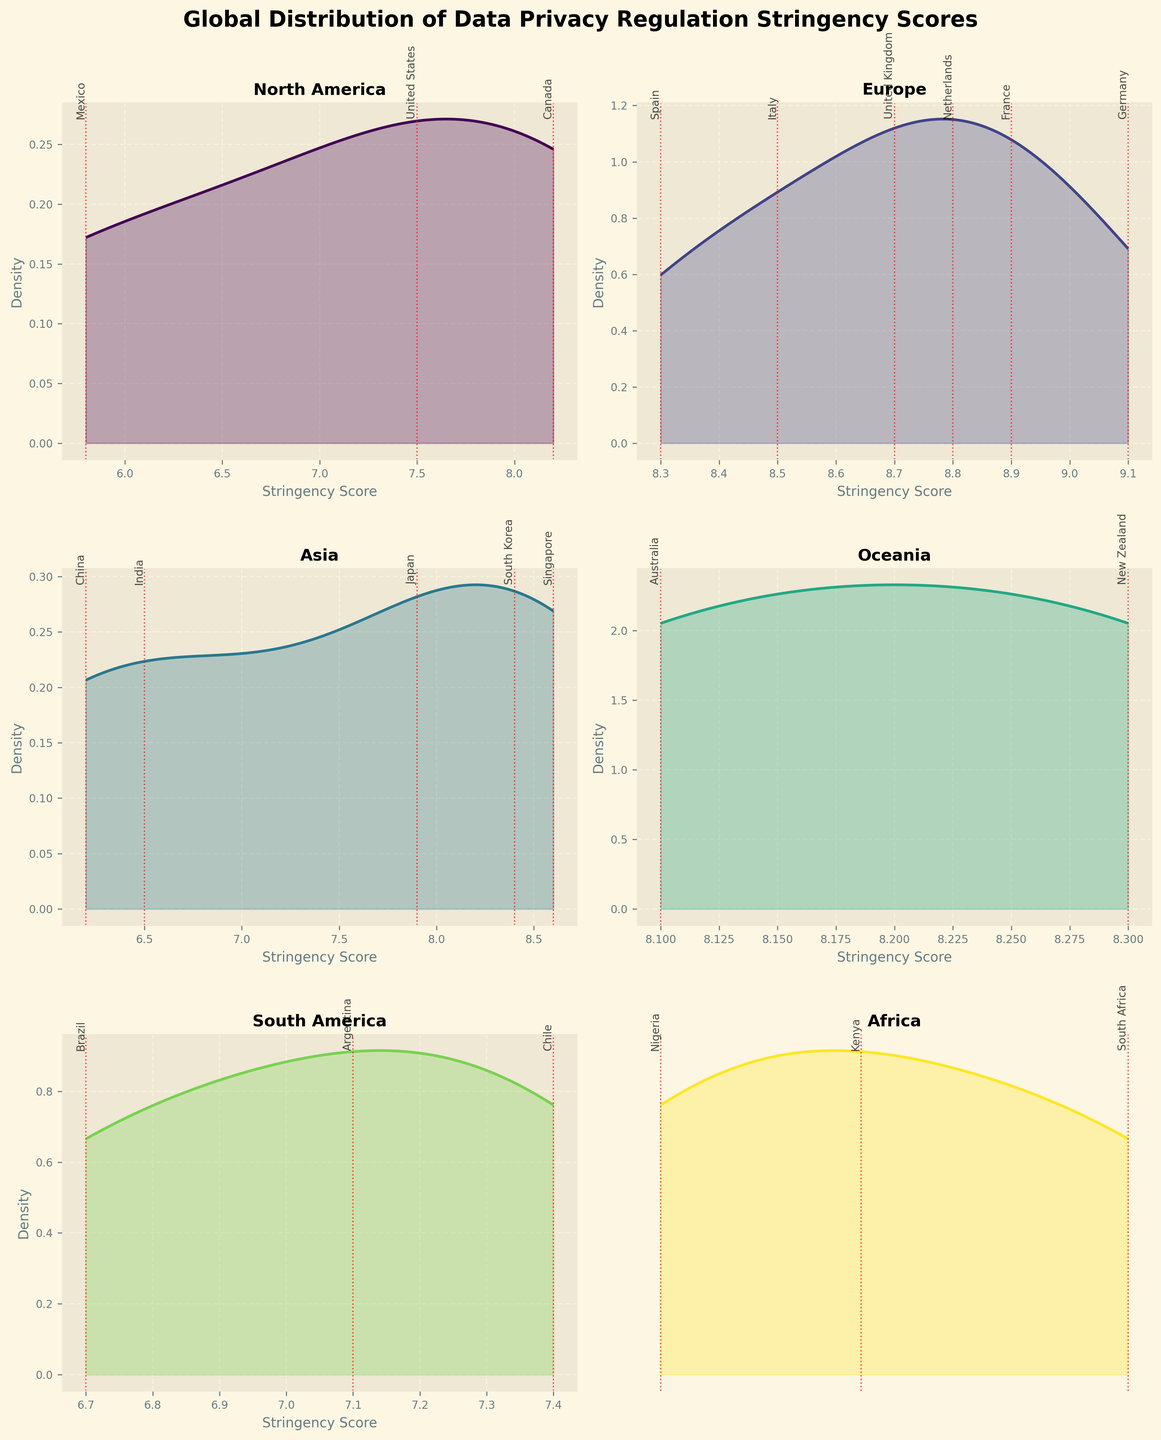Which region has the highest density peak? The density peak is where the curve reaches its highest point. Europe has the tallest peak, indicating the greatest density.
Answer: Europe Which region exhibits the widest range of stringency scores? The range is indicated by the span of the x-axis. Africa shows the widest range of scores, from approx 5.5 to 6.9.
Answer: Africa What is the median score for Europe based on visual inspection? Looking at the European countries, the median would fall around the middle score. Visually, the median seems around 8.6 or 8.7.
Answer: 8.6-8.7 Which country has the lowest data privacy regulation stringency score? The lowest score corresponds to the leftmost vertical line. Nigeria has the lowest score at 5.5.
Answer: Nigeria Which region shows the least variation in stringency scores? Least variation is observed where the density plot is narrowest. Oceania appears to have the least variation with scores clustered around 8.1 to 8.3.
Answer: Oceania How do the peaks of North America and South America compare? Comparing the height and position of peaks, North America's peak is higher but falls around the middle of the range, while South America's peak is shorter and towards the lower end.
Answer: North America's peak is higher and centered Which two regions have density curves that seem most similar? Similar curves would have similar shapes and peaks. Oceania and Europe have similarly shaped curves, both with high stringency scores and narrow variance.
Answer: Oceania and Europe In Asia, which country's stringency score is closest to the peak of the density curve? The peak indicates the highest density, around 8.0. Japan’s score of 7.9 is closest to this peak.
Answer: Japan How many countries in Europe have a stringency score above 8.5? Vertical lines above 8.5 are found for the UK, Germany, France, Netherlands, and Italy. There are five such countries.
Answer: 5 countries Is there any region without a country having a score below 7? Evaluating each subplot, Oceania has no country with scores below 7.
Answer: Oceania 